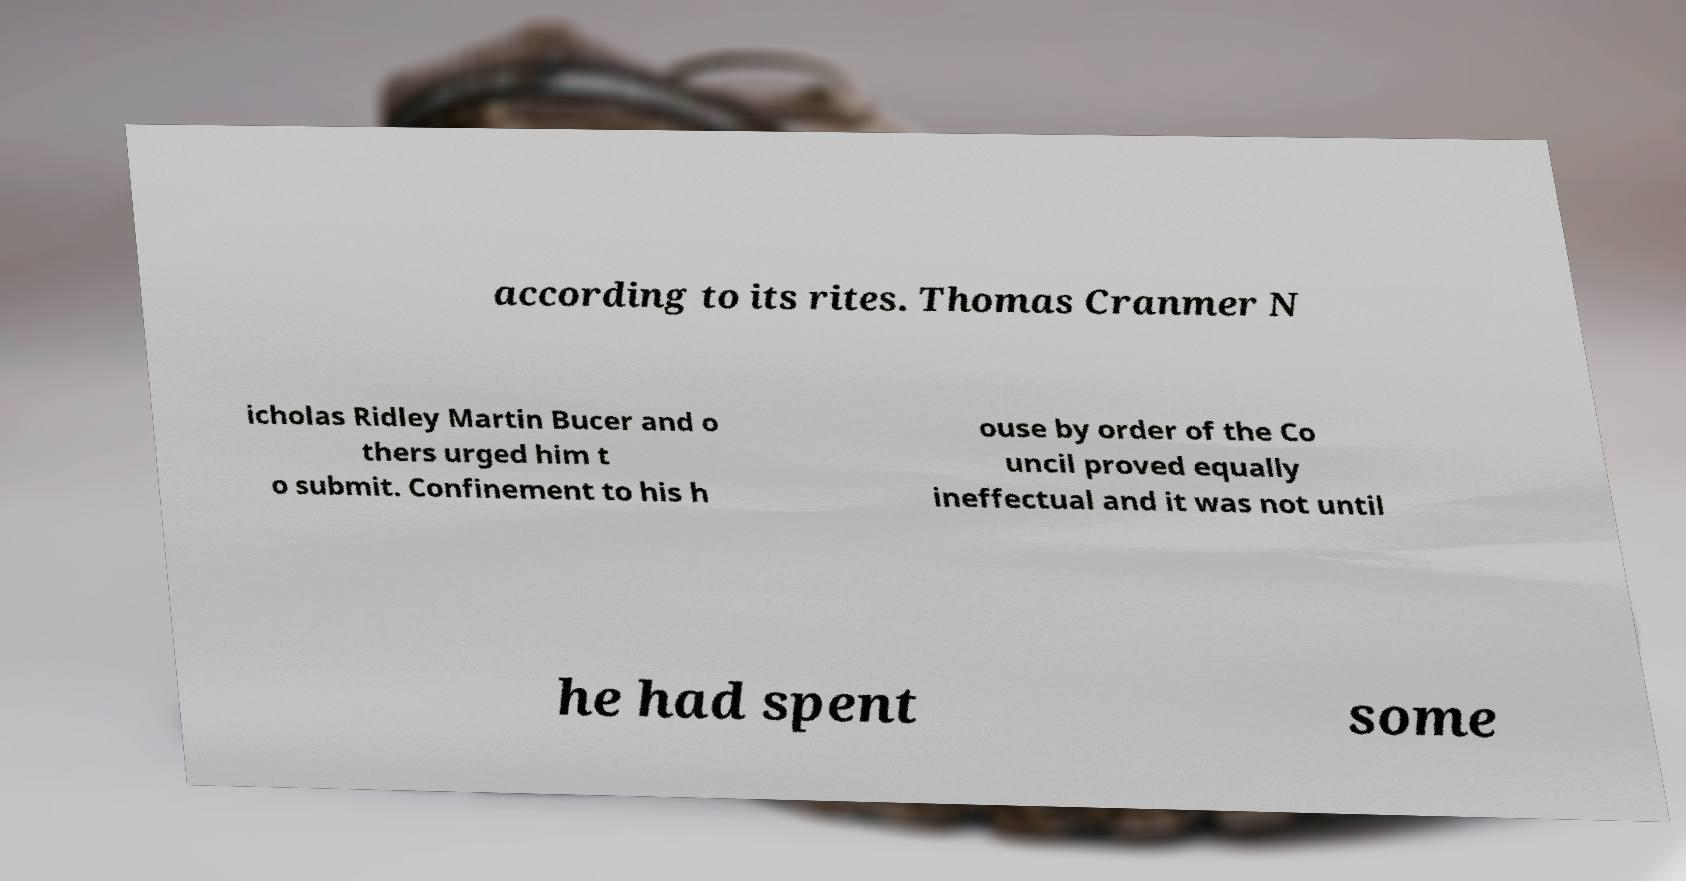Please identify and transcribe the text found in this image. according to its rites. Thomas Cranmer N icholas Ridley Martin Bucer and o thers urged him t o submit. Confinement to his h ouse by order of the Co uncil proved equally ineffectual and it was not until he had spent some 